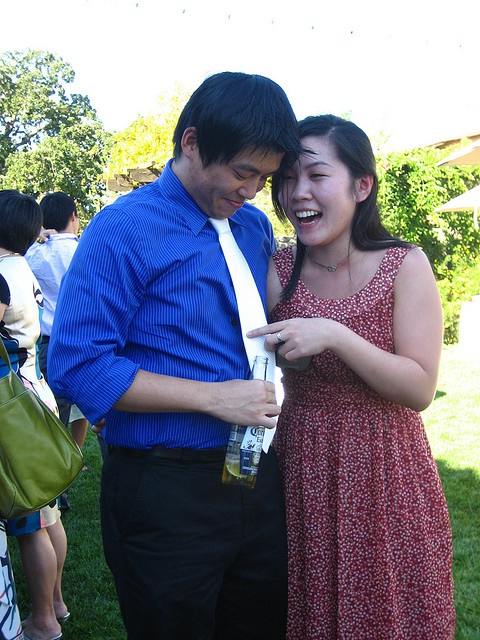Describe the objects in this image and their specific colors. I can see people in white, black, blue, darkblue, and navy tones, people in white, purple, black, gray, and darkgray tones, people in white, black, gray, and navy tones, handbag in white, darkgreen, green, and black tones, and people in white, lavender, black, blue, and lightblue tones in this image. 